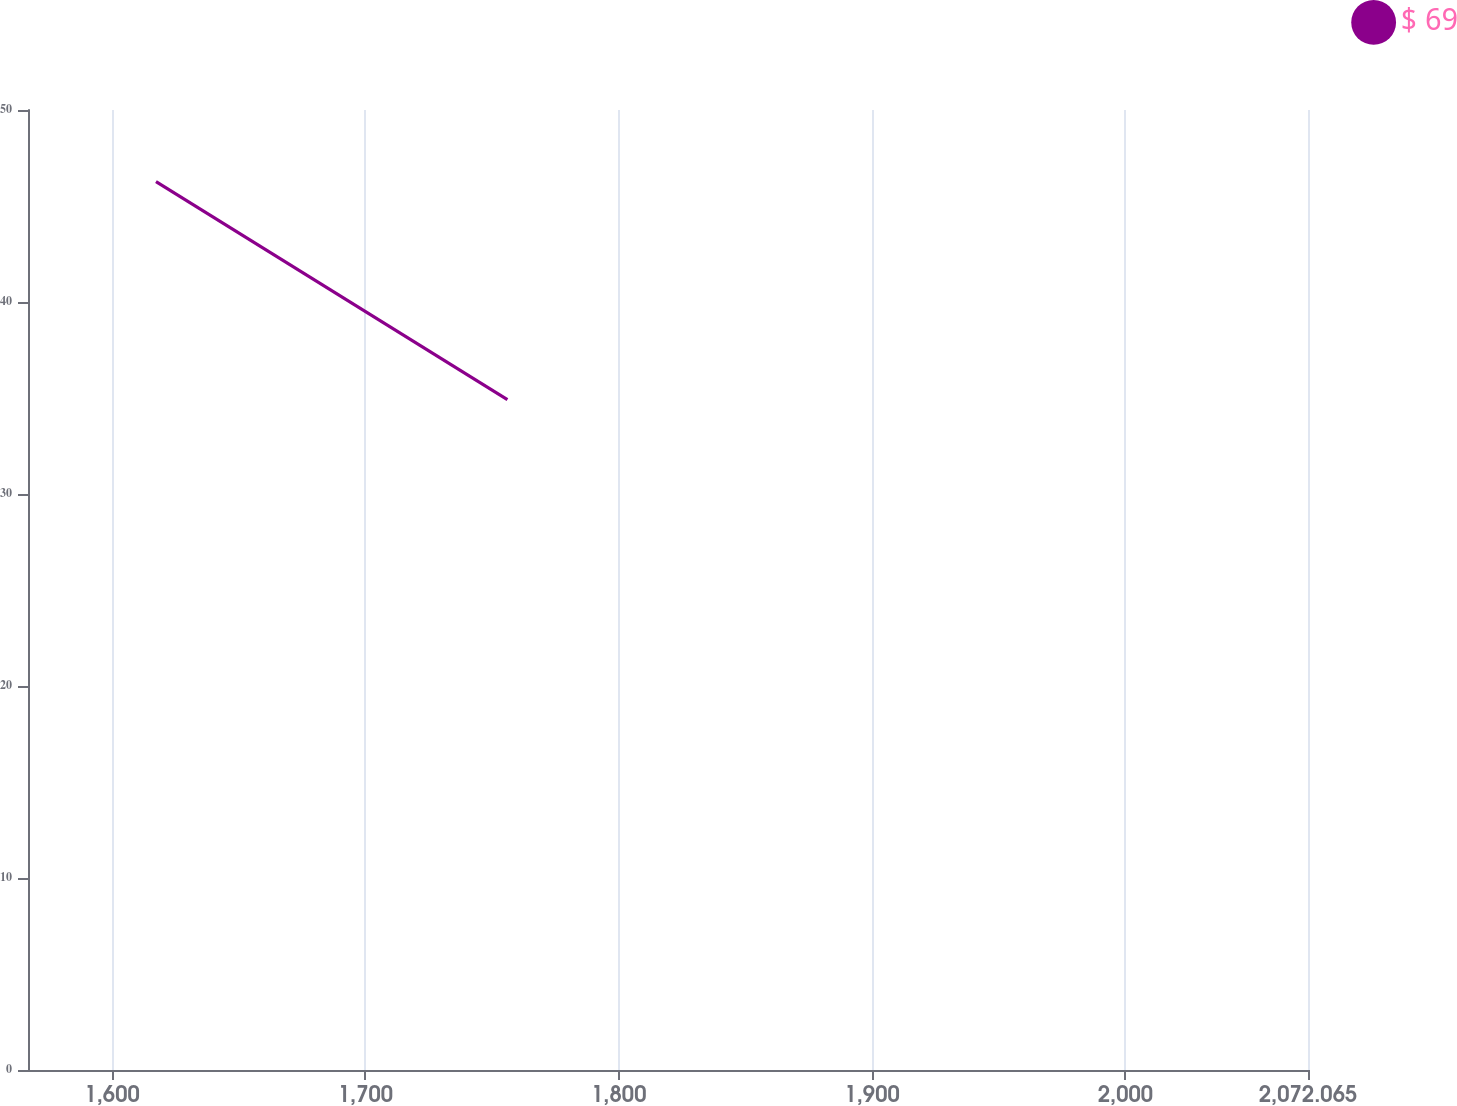Convert chart to OTSL. <chart><loc_0><loc_0><loc_500><loc_500><line_chart><ecel><fcel>$ 69<nl><fcel>1617.34<fcel>46.27<nl><fcel>1756.06<fcel>34.91<nl><fcel>2073.48<fcel>37.87<nl><fcel>2122.59<fcel>24.3<nl></chart> 